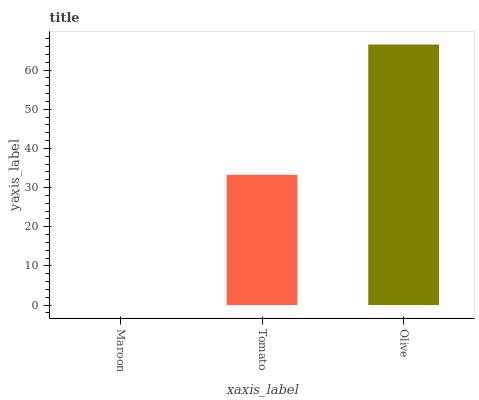Is Maroon the minimum?
Answer yes or no. Yes. Is Olive the maximum?
Answer yes or no. Yes. Is Tomato the minimum?
Answer yes or no. No. Is Tomato the maximum?
Answer yes or no. No. Is Tomato greater than Maroon?
Answer yes or no. Yes. Is Maroon less than Tomato?
Answer yes or no. Yes. Is Maroon greater than Tomato?
Answer yes or no. No. Is Tomato less than Maroon?
Answer yes or no. No. Is Tomato the high median?
Answer yes or no. Yes. Is Tomato the low median?
Answer yes or no. Yes. Is Maroon the high median?
Answer yes or no. No. Is Maroon the low median?
Answer yes or no. No. 